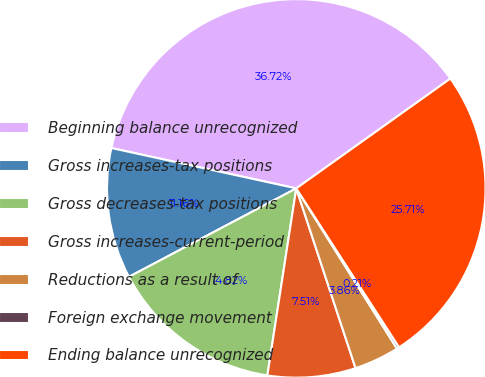Convert chart to OTSL. <chart><loc_0><loc_0><loc_500><loc_500><pie_chart><fcel>Beginning balance unrecognized<fcel>Gross increases-tax positions<fcel>Gross decreases-tax positions<fcel>Gross increases-current-period<fcel>Reductions as a result of<fcel>Foreign exchange movement<fcel>Ending balance unrecognized<nl><fcel>36.72%<fcel>11.16%<fcel>14.82%<fcel>7.51%<fcel>3.86%<fcel>0.21%<fcel>25.71%<nl></chart> 